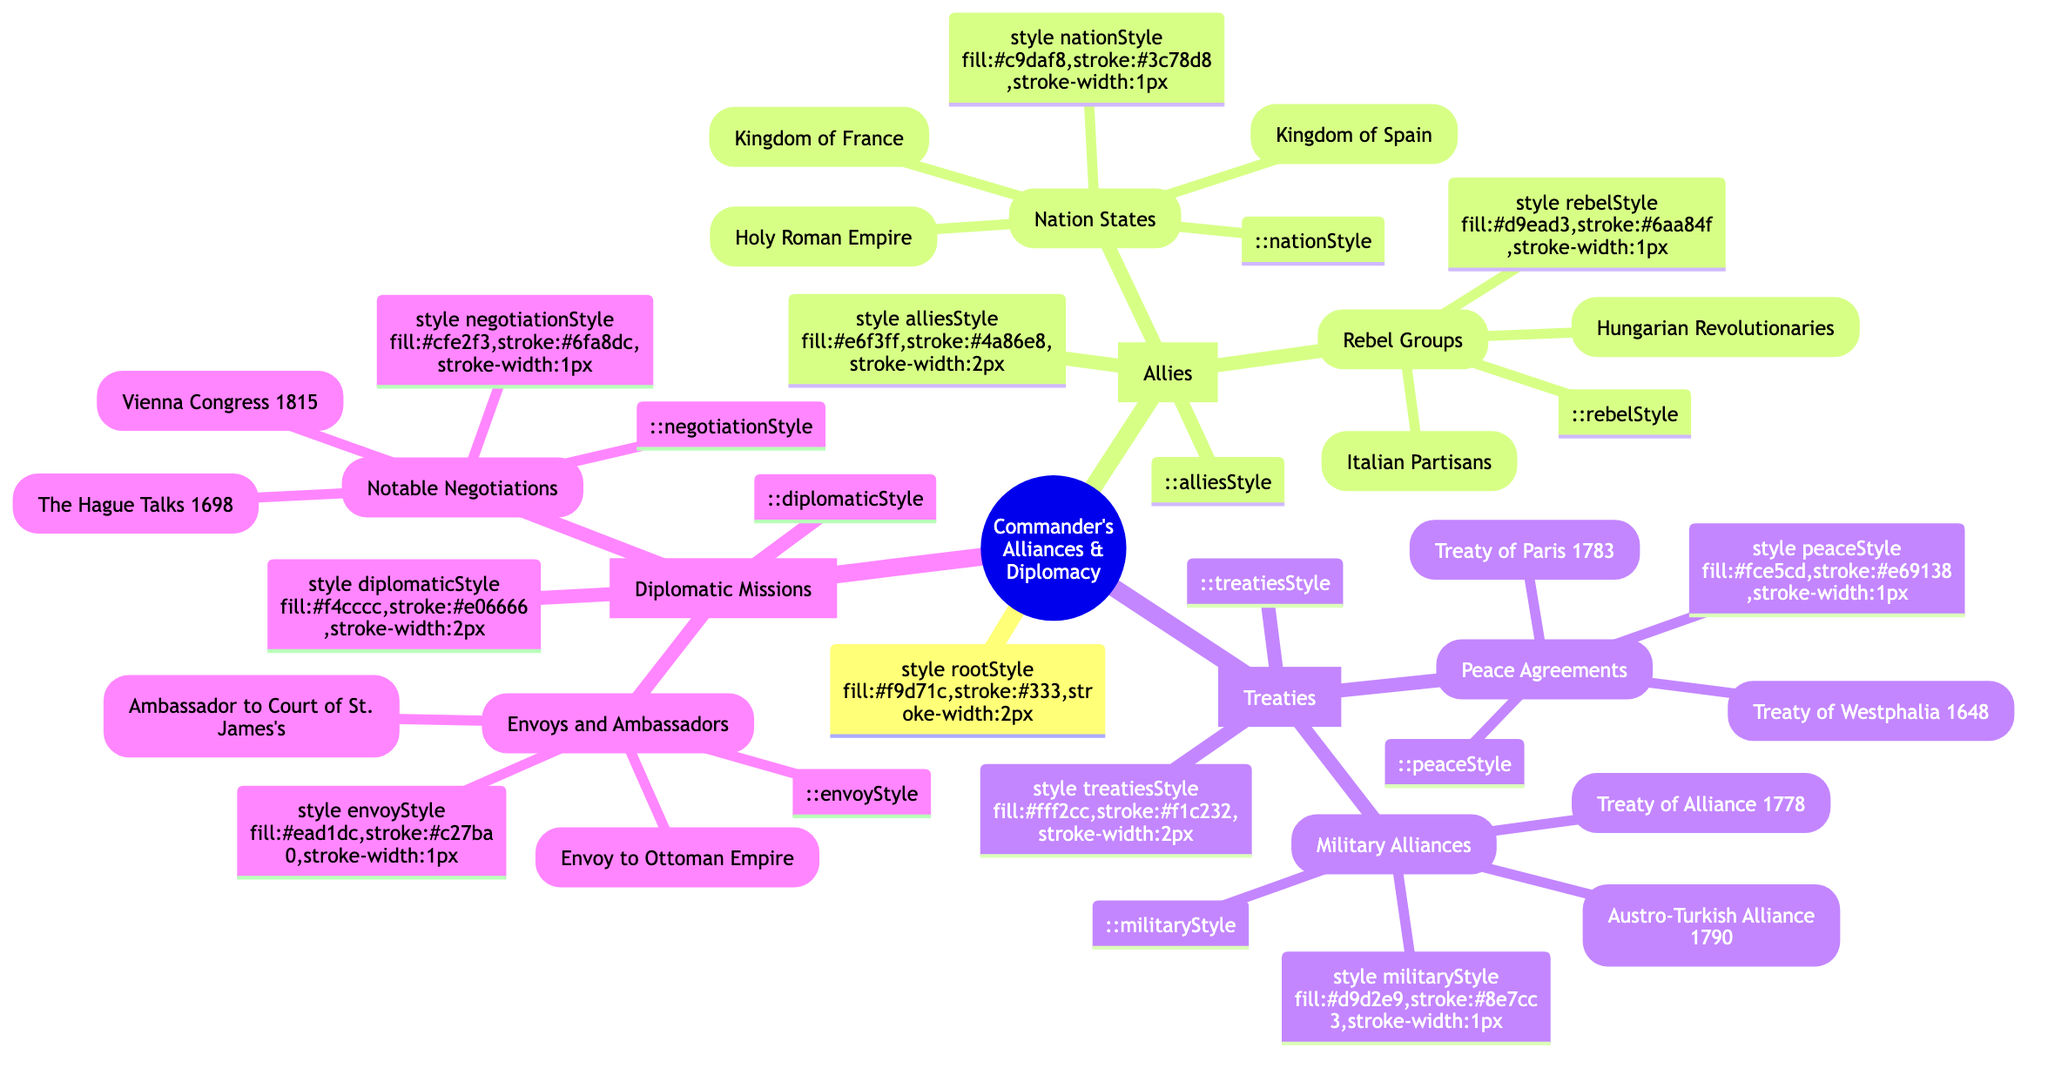What are the names of the nation states allied with the commander? The diagram provides a list under the "Nation States" category within "Allies," which includes "Kingdom of France," "Kingdom of Spain," and "Holy Roman Empire."
Answer: Kingdom of France, Kingdom of Spain, Holy Roman Empire How many rebel groups are mentioned as allies? The "Rebel Groups" category in the "Allies" section lists two groups: "Hungarian Revolutionaries" and "Italian Partisans." Therefore, the total is counted as two.
Answer: 2 What is one of the peace agreements made by the commander? Referring to the "Peace Agreements" under "Treaties," the diagram mentions two treaties: "Treaty of Paris (1783)" and "Treaty of Westphalia (1648)." Any of these can be cited as an example.
Answer: Treaty of Paris (1783) Which treaty corresponds to military alliances? The "Military Alliances" category under "Treaties" specifically lists the "Treaty of Alliance (1778)" and "Austro-Turkish Alliance (1790)," thus any of these can be a valid example for military alliances.
Answer: Treaty of Alliance (1778) What mission did the commander send to the Ottoman Empire? The "Envoys and Ambassadors" section within "Diplomatic Missions" includes "Envoy to the Ottoman Empire," indicating this specific mission.
Answer: Envoy to the Ottoman Empire How many notable negotiations are listed in the diagram? The "Notable Negotiations" section under "Diplomatic Missions" counts two instances: "Vienna Congress Negotiations (1815)" and "Diplomatic Talks at The Hague (1698)." Therefore, the total number is two.
Answer: 2 What type of diagram is represented here? Given the structure and organization laid out in the diagram, it is characterized as a "Mind Map," a visual representation that organizes information hierarchically.
Answer: Mind Map Which nations were allied through the 1778 treaty? The "Treaty of Alliance (1778)" is categorized under "Military Alliances," which signifies a military pact with the corresponding nations listed as allies in the diagram.
Answer: Kingdom of France, Kingdom of Spain, Holy Roman Empire Which notable negotiation took place in 1815? The “Notable Negotiations” section lists "Vienna Congress Negotiations (1815)," making it explicit as the key event in that year.
Answer: Vienna Congress Negotiations (1815) 